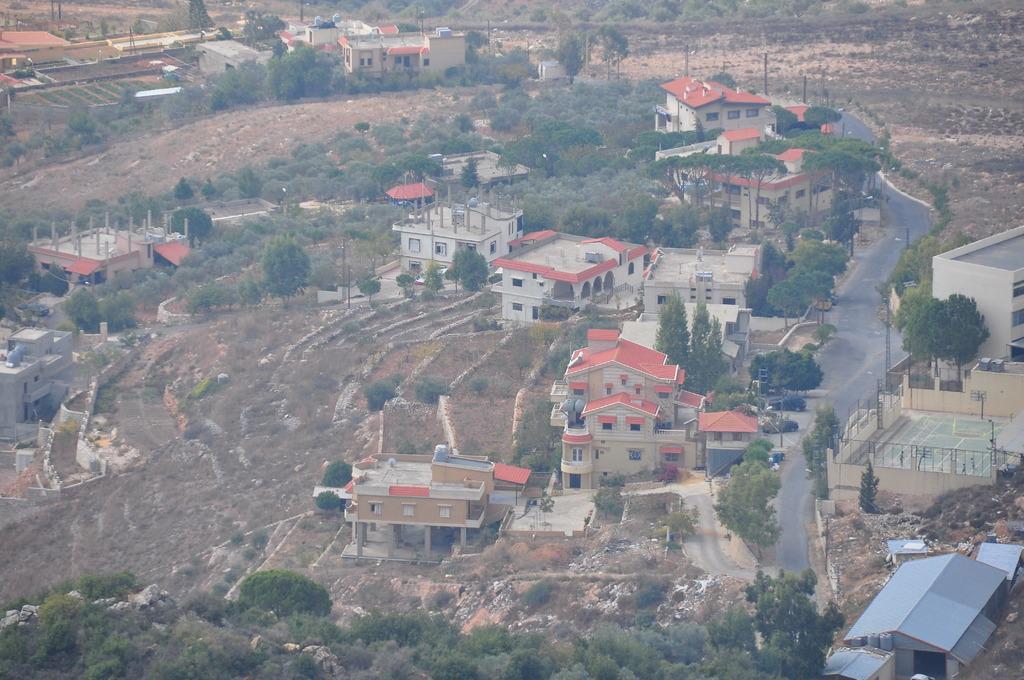In one or two sentences, can you explain what this image depicts? Here we can see houses, trees, plants, and poles. There is a road. 